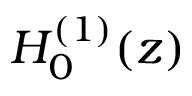Convert formula to latex. <formula><loc_0><loc_0><loc_500><loc_500>H _ { 0 } ^ { ( 1 ) } ( z )</formula> 